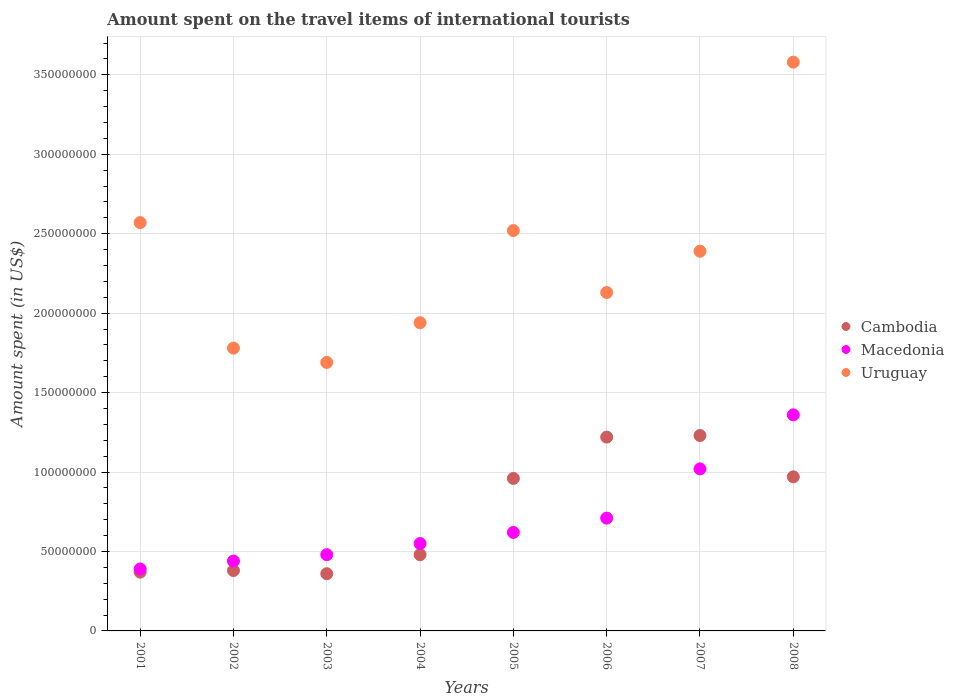How many different coloured dotlines are there?
Ensure brevity in your answer.  3. Is the number of dotlines equal to the number of legend labels?
Keep it short and to the point. Yes. What is the amount spent on the travel items of international tourists in Uruguay in 2007?
Offer a very short reply. 2.39e+08. Across all years, what is the maximum amount spent on the travel items of international tourists in Cambodia?
Ensure brevity in your answer.  1.23e+08. Across all years, what is the minimum amount spent on the travel items of international tourists in Uruguay?
Your answer should be very brief. 1.69e+08. In which year was the amount spent on the travel items of international tourists in Uruguay maximum?
Provide a succinct answer. 2008. What is the total amount spent on the travel items of international tourists in Macedonia in the graph?
Provide a succinct answer. 5.57e+08. What is the difference between the amount spent on the travel items of international tourists in Macedonia in 2001 and that in 2008?
Your answer should be compact. -9.70e+07. What is the difference between the amount spent on the travel items of international tourists in Cambodia in 2005 and the amount spent on the travel items of international tourists in Macedonia in 2008?
Your answer should be compact. -4.00e+07. What is the average amount spent on the travel items of international tourists in Cambodia per year?
Your response must be concise. 7.46e+07. In the year 2005, what is the difference between the amount spent on the travel items of international tourists in Cambodia and amount spent on the travel items of international tourists in Uruguay?
Provide a succinct answer. -1.56e+08. What is the ratio of the amount spent on the travel items of international tourists in Cambodia in 2001 to that in 2002?
Provide a succinct answer. 0.97. What is the difference between the highest and the second highest amount spent on the travel items of international tourists in Macedonia?
Your answer should be very brief. 3.40e+07. What is the difference between the highest and the lowest amount spent on the travel items of international tourists in Macedonia?
Your response must be concise. 9.70e+07. Is the amount spent on the travel items of international tourists in Cambodia strictly greater than the amount spent on the travel items of international tourists in Uruguay over the years?
Make the answer very short. No. Is the amount spent on the travel items of international tourists in Cambodia strictly less than the amount spent on the travel items of international tourists in Uruguay over the years?
Make the answer very short. Yes. How many dotlines are there?
Make the answer very short. 3. Does the graph contain grids?
Your answer should be very brief. Yes. Where does the legend appear in the graph?
Ensure brevity in your answer.  Center right. What is the title of the graph?
Provide a short and direct response. Amount spent on the travel items of international tourists. Does "Guatemala" appear as one of the legend labels in the graph?
Make the answer very short. No. What is the label or title of the Y-axis?
Give a very brief answer. Amount spent (in US$). What is the Amount spent (in US$) of Cambodia in 2001?
Ensure brevity in your answer.  3.70e+07. What is the Amount spent (in US$) in Macedonia in 2001?
Your response must be concise. 3.90e+07. What is the Amount spent (in US$) in Uruguay in 2001?
Provide a short and direct response. 2.57e+08. What is the Amount spent (in US$) in Cambodia in 2002?
Give a very brief answer. 3.80e+07. What is the Amount spent (in US$) in Macedonia in 2002?
Provide a succinct answer. 4.40e+07. What is the Amount spent (in US$) in Uruguay in 2002?
Offer a terse response. 1.78e+08. What is the Amount spent (in US$) of Cambodia in 2003?
Your answer should be compact. 3.60e+07. What is the Amount spent (in US$) in Macedonia in 2003?
Provide a succinct answer. 4.80e+07. What is the Amount spent (in US$) in Uruguay in 2003?
Offer a very short reply. 1.69e+08. What is the Amount spent (in US$) in Cambodia in 2004?
Your answer should be compact. 4.80e+07. What is the Amount spent (in US$) in Macedonia in 2004?
Keep it short and to the point. 5.50e+07. What is the Amount spent (in US$) of Uruguay in 2004?
Your answer should be very brief. 1.94e+08. What is the Amount spent (in US$) in Cambodia in 2005?
Your answer should be compact. 9.60e+07. What is the Amount spent (in US$) of Macedonia in 2005?
Offer a very short reply. 6.20e+07. What is the Amount spent (in US$) in Uruguay in 2005?
Keep it short and to the point. 2.52e+08. What is the Amount spent (in US$) in Cambodia in 2006?
Your response must be concise. 1.22e+08. What is the Amount spent (in US$) in Macedonia in 2006?
Provide a succinct answer. 7.10e+07. What is the Amount spent (in US$) of Uruguay in 2006?
Make the answer very short. 2.13e+08. What is the Amount spent (in US$) in Cambodia in 2007?
Your response must be concise. 1.23e+08. What is the Amount spent (in US$) in Macedonia in 2007?
Give a very brief answer. 1.02e+08. What is the Amount spent (in US$) in Uruguay in 2007?
Ensure brevity in your answer.  2.39e+08. What is the Amount spent (in US$) of Cambodia in 2008?
Ensure brevity in your answer.  9.70e+07. What is the Amount spent (in US$) of Macedonia in 2008?
Offer a terse response. 1.36e+08. What is the Amount spent (in US$) of Uruguay in 2008?
Your answer should be compact. 3.58e+08. Across all years, what is the maximum Amount spent (in US$) in Cambodia?
Provide a short and direct response. 1.23e+08. Across all years, what is the maximum Amount spent (in US$) of Macedonia?
Ensure brevity in your answer.  1.36e+08. Across all years, what is the maximum Amount spent (in US$) in Uruguay?
Your answer should be compact. 3.58e+08. Across all years, what is the minimum Amount spent (in US$) in Cambodia?
Give a very brief answer. 3.60e+07. Across all years, what is the minimum Amount spent (in US$) of Macedonia?
Offer a very short reply. 3.90e+07. Across all years, what is the minimum Amount spent (in US$) of Uruguay?
Your response must be concise. 1.69e+08. What is the total Amount spent (in US$) of Cambodia in the graph?
Ensure brevity in your answer.  5.97e+08. What is the total Amount spent (in US$) in Macedonia in the graph?
Offer a terse response. 5.57e+08. What is the total Amount spent (in US$) in Uruguay in the graph?
Make the answer very short. 1.86e+09. What is the difference between the Amount spent (in US$) of Macedonia in 2001 and that in 2002?
Ensure brevity in your answer.  -5.00e+06. What is the difference between the Amount spent (in US$) of Uruguay in 2001 and that in 2002?
Offer a very short reply. 7.90e+07. What is the difference between the Amount spent (in US$) of Macedonia in 2001 and that in 2003?
Provide a short and direct response. -9.00e+06. What is the difference between the Amount spent (in US$) in Uruguay in 2001 and that in 2003?
Offer a terse response. 8.80e+07. What is the difference between the Amount spent (in US$) in Cambodia in 2001 and that in 2004?
Offer a very short reply. -1.10e+07. What is the difference between the Amount spent (in US$) of Macedonia in 2001 and that in 2004?
Your answer should be compact. -1.60e+07. What is the difference between the Amount spent (in US$) in Uruguay in 2001 and that in 2004?
Offer a terse response. 6.30e+07. What is the difference between the Amount spent (in US$) in Cambodia in 2001 and that in 2005?
Your response must be concise. -5.90e+07. What is the difference between the Amount spent (in US$) in Macedonia in 2001 and that in 2005?
Provide a short and direct response. -2.30e+07. What is the difference between the Amount spent (in US$) in Uruguay in 2001 and that in 2005?
Offer a terse response. 5.00e+06. What is the difference between the Amount spent (in US$) in Cambodia in 2001 and that in 2006?
Provide a short and direct response. -8.50e+07. What is the difference between the Amount spent (in US$) of Macedonia in 2001 and that in 2006?
Give a very brief answer. -3.20e+07. What is the difference between the Amount spent (in US$) of Uruguay in 2001 and that in 2006?
Keep it short and to the point. 4.40e+07. What is the difference between the Amount spent (in US$) in Cambodia in 2001 and that in 2007?
Your answer should be very brief. -8.60e+07. What is the difference between the Amount spent (in US$) in Macedonia in 2001 and that in 2007?
Ensure brevity in your answer.  -6.30e+07. What is the difference between the Amount spent (in US$) of Uruguay in 2001 and that in 2007?
Offer a terse response. 1.80e+07. What is the difference between the Amount spent (in US$) of Cambodia in 2001 and that in 2008?
Your answer should be very brief. -6.00e+07. What is the difference between the Amount spent (in US$) in Macedonia in 2001 and that in 2008?
Make the answer very short. -9.70e+07. What is the difference between the Amount spent (in US$) in Uruguay in 2001 and that in 2008?
Keep it short and to the point. -1.01e+08. What is the difference between the Amount spent (in US$) in Uruguay in 2002 and that in 2003?
Provide a short and direct response. 9.00e+06. What is the difference between the Amount spent (in US$) of Cambodia in 2002 and that in 2004?
Give a very brief answer. -1.00e+07. What is the difference between the Amount spent (in US$) of Macedonia in 2002 and that in 2004?
Offer a very short reply. -1.10e+07. What is the difference between the Amount spent (in US$) of Uruguay in 2002 and that in 2004?
Give a very brief answer. -1.60e+07. What is the difference between the Amount spent (in US$) of Cambodia in 2002 and that in 2005?
Provide a short and direct response. -5.80e+07. What is the difference between the Amount spent (in US$) in Macedonia in 2002 and that in 2005?
Offer a terse response. -1.80e+07. What is the difference between the Amount spent (in US$) in Uruguay in 2002 and that in 2005?
Your answer should be compact. -7.40e+07. What is the difference between the Amount spent (in US$) in Cambodia in 2002 and that in 2006?
Offer a terse response. -8.40e+07. What is the difference between the Amount spent (in US$) in Macedonia in 2002 and that in 2006?
Provide a succinct answer. -2.70e+07. What is the difference between the Amount spent (in US$) of Uruguay in 2002 and that in 2006?
Give a very brief answer. -3.50e+07. What is the difference between the Amount spent (in US$) in Cambodia in 2002 and that in 2007?
Offer a very short reply. -8.50e+07. What is the difference between the Amount spent (in US$) in Macedonia in 2002 and that in 2007?
Give a very brief answer. -5.80e+07. What is the difference between the Amount spent (in US$) of Uruguay in 2002 and that in 2007?
Provide a succinct answer. -6.10e+07. What is the difference between the Amount spent (in US$) of Cambodia in 2002 and that in 2008?
Offer a terse response. -5.90e+07. What is the difference between the Amount spent (in US$) of Macedonia in 2002 and that in 2008?
Give a very brief answer. -9.20e+07. What is the difference between the Amount spent (in US$) in Uruguay in 2002 and that in 2008?
Ensure brevity in your answer.  -1.80e+08. What is the difference between the Amount spent (in US$) in Cambodia in 2003 and that in 2004?
Ensure brevity in your answer.  -1.20e+07. What is the difference between the Amount spent (in US$) in Macedonia in 2003 and that in 2004?
Provide a short and direct response. -7.00e+06. What is the difference between the Amount spent (in US$) of Uruguay in 2003 and that in 2004?
Your answer should be very brief. -2.50e+07. What is the difference between the Amount spent (in US$) in Cambodia in 2003 and that in 2005?
Make the answer very short. -6.00e+07. What is the difference between the Amount spent (in US$) in Macedonia in 2003 and that in 2005?
Your response must be concise. -1.40e+07. What is the difference between the Amount spent (in US$) of Uruguay in 2003 and that in 2005?
Your response must be concise. -8.30e+07. What is the difference between the Amount spent (in US$) in Cambodia in 2003 and that in 2006?
Ensure brevity in your answer.  -8.60e+07. What is the difference between the Amount spent (in US$) in Macedonia in 2003 and that in 2006?
Make the answer very short. -2.30e+07. What is the difference between the Amount spent (in US$) of Uruguay in 2003 and that in 2006?
Your response must be concise. -4.40e+07. What is the difference between the Amount spent (in US$) in Cambodia in 2003 and that in 2007?
Your response must be concise. -8.70e+07. What is the difference between the Amount spent (in US$) of Macedonia in 2003 and that in 2007?
Make the answer very short. -5.40e+07. What is the difference between the Amount spent (in US$) in Uruguay in 2003 and that in 2007?
Give a very brief answer. -7.00e+07. What is the difference between the Amount spent (in US$) in Cambodia in 2003 and that in 2008?
Offer a very short reply. -6.10e+07. What is the difference between the Amount spent (in US$) of Macedonia in 2003 and that in 2008?
Offer a very short reply. -8.80e+07. What is the difference between the Amount spent (in US$) of Uruguay in 2003 and that in 2008?
Your answer should be compact. -1.89e+08. What is the difference between the Amount spent (in US$) in Cambodia in 2004 and that in 2005?
Provide a succinct answer. -4.80e+07. What is the difference between the Amount spent (in US$) in Macedonia in 2004 and that in 2005?
Your answer should be compact. -7.00e+06. What is the difference between the Amount spent (in US$) of Uruguay in 2004 and that in 2005?
Keep it short and to the point. -5.80e+07. What is the difference between the Amount spent (in US$) of Cambodia in 2004 and that in 2006?
Keep it short and to the point. -7.40e+07. What is the difference between the Amount spent (in US$) in Macedonia in 2004 and that in 2006?
Offer a terse response. -1.60e+07. What is the difference between the Amount spent (in US$) of Uruguay in 2004 and that in 2006?
Your answer should be very brief. -1.90e+07. What is the difference between the Amount spent (in US$) of Cambodia in 2004 and that in 2007?
Keep it short and to the point. -7.50e+07. What is the difference between the Amount spent (in US$) in Macedonia in 2004 and that in 2007?
Provide a short and direct response. -4.70e+07. What is the difference between the Amount spent (in US$) of Uruguay in 2004 and that in 2007?
Offer a terse response. -4.50e+07. What is the difference between the Amount spent (in US$) of Cambodia in 2004 and that in 2008?
Provide a succinct answer. -4.90e+07. What is the difference between the Amount spent (in US$) in Macedonia in 2004 and that in 2008?
Offer a very short reply. -8.10e+07. What is the difference between the Amount spent (in US$) in Uruguay in 2004 and that in 2008?
Your answer should be very brief. -1.64e+08. What is the difference between the Amount spent (in US$) in Cambodia in 2005 and that in 2006?
Provide a succinct answer. -2.60e+07. What is the difference between the Amount spent (in US$) of Macedonia in 2005 and that in 2006?
Keep it short and to the point. -9.00e+06. What is the difference between the Amount spent (in US$) in Uruguay in 2005 and that in 2006?
Your answer should be very brief. 3.90e+07. What is the difference between the Amount spent (in US$) of Cambodia in 2005 and that in 2007?
Your answer should be very brief. -2.70e+07. What is the difference between the Amount spent (in US$) in Macedonia in 2005 and that in 2007?
Provide a short and direct response. -4.00e+07. What is the difference between the Amount spent (in US$) in Uruguay in 2005 and that in 2007?
Offer a very short reply. 1.30e+07. What is the difference between the Amount spent (in US$) of Macedonia in 2005 and that in 2008?
Provide a succinct answer. -7.40e+07. What is the difference between the Amount spent (in US$) in Uruguay in 2005 and that in 2008?
Ensure brevity in your answer.  -1.06e+08. What is the difference between the Amount spent (in US$) in Macedonia in 2006 and that in 2007?
Make the answer very short. -3.10e+07. What is the difference between the Amount spent (in US$) of Uruguay in 2006 and that in 2007?
Your response must be concise. -2.60e+07. What is the difference between the Amount spent (in US$) in Cambodia in 2006 and that in 2008?
Give a very brief answer. 2.50e+07. What is the difference between the Amount spent (in US$) in Macedonia in 2006 and that in 2008?
Your answer should be very brief. -6.50e+07. What is the difference between the Amount spent (in US$) in Uruguay in 2006 and that in 2008?
Ensure brevity in your answer.  -1.45e+08. What is the difference between the Amount spent (in US$) of Cambodia in 2007 and that in 2008?
Provide a succinct answer. 2.60e+07. What is the difference between the Amount spent (in US$) in Macedonia in 2007 and that in 2008?
Keep it short and to the point. -3.40e+07. What is the difference between the Amount spent (in US$) in Uruguay in 2007 and that in 2008?
Offer a very short reply. -1.19e+08. What is the difference between the Amount spent (in US$) of Cambodia in 2001 and the Amount spent (in US$) of Macedonia in 2002?
Offer a terse response. -7.00e+06. What is the difference between the Amount spent (in US$) in Cambodia in 2001 and the Amount spent (in US$) in Uruguay in 2002?
Ensure brevity in your answer.  -1.41e+08. What is the difference between the Amount spent (in US$) of Macedonia in 2001 and the Amount spent (in US$) of Uruguay in 2002?
Ensure brevity in your answer.  -1.39e+08. What is the difference between the Amount spent (in US$) of Cambodia in 2001 and the Amount spent (in US$) of Macedonia in 2003?
Keep it short and to the point. -1.10e+07. What is the difference between the Amount spent (in US$) in Cambodia in 2001 and the Amount spent (in US$) in Uruguay in 2003?
Your answer should be compact. -1.32e+08. What is the difference between the Amount spent (in US$) in Macedonia in 2001 and the Amount spent (in US$) in Uruguay in 2003?
Your answer should be compact. -1.30e+08. What is the difference between the Amount spent (in US$) of Cambodia in 2001 and the Amount spent (in US$) of Macedonia in 2004?
Your answer should be very brief. -1.80e+07. What is the difference between the Amount spent (in US$) in Cambodia in 2001 and the Amount spent (in US$) in Uruguay in 2004?
Offer a terse response. -1.57e+08. What is the difference between the Amount spent (in US$) in Macedonia in 2001 and the Amount spent (in US$) in Uruguay in 2004?
Your response must be concise. -1.55e+08. What is the difference between the Amount spent (in US$) of Cambodia in 2001 and the Amount spent (in US$) of Macedonia in 2005?
Your response must be concise. -2.50e+07. What is the difference between the Amount spent (in US$) of Cambodia in 2001 and the Amount spent (in US$) of Uruguay in 2005?
Your answer should be very brief. -2.15e+08. What is the difference between the Amount spent (in US$) of Macedonia in 2001 and the Amount spent (in US$) of Uruguay in 2005?
Ensure brevity in your answer.  -2.13e+08. What is the difference between the Amount spent (in US$) of Cambodia in 2001 and the Amount spent (in US$) of Macedonia in 2006?
Your answer should be compact. -3.40e+07. What is the difference between the Amount spent (in US$) in Cambodia in 2001 and the Amount spent (in US$) in Uruguay in 2006?
Give a very brief answer. -1.76e+08. What is the difference between the Amount spent (in US$) in Macedonia in 2001 and the Amount spent (in US$) in Uruguay in 2006?
Your answer should be very brief. -1.74e+08. What is the difference between the Amount spent (in US$) in Cambodia in 2001 and the Amount spent (in US$) in Macedonia in 2007?
Offer a terse response. -6.50e+07. What is the difference between the Amount spent (in US$) in Cambodia in 2001 and the Amount spent (in US$) in Uruguay in 2007?
Your response must be concise. -2.02e+08. What is the difference between the Amount spent (in US$) in Macedonia in 2001 and the Amount spent (in US$) in Uruguay in 2007?
Keep it short and to the point. -2.00e+08. What is the difference between the Amount spent (in US$) of Cambodia in 2001 and the Amount spent (in US$) of Macedonia in 2008?
Keep it short and to the point. -9.90e+07. What is the difference between the Amount spent (in US$) of Cambodia in 2001 and the Amount spent (in US$) of Uruguay in 2008?
Ensure brevity in your answer.  -3.21e+08. What is the difference between the Amount spent (in US$) of Macedonia in 2001 and the Amount spent (in US$) of Uruguay in 2008?
Your answer should be compact. -3.19e+08. What is the difference between the Amount spent (in US$) in Cambodia in 2002 and the Amount spent (in US$) in Macedonia in 2003?
Your answer should be very brief. -1.00e+07. What is the difference between the Amount spent (in US$) of Cambodia in 2002 and the Amount spent (in US$) of Uruguay in 2003?
Provide a short and direct response. -1.31e+08. What is the difference between the Amount spent (in US$) in Macedonia in 2002 and the Amount spent (in US$) in Uruguay in 2003?
Keep it short and to the point. -1.25e+08. What is the difference between the Amount spent (in US$) in Cambodia in 2002 and the Amount spent (in US$) in Macedonia in 2004?
Your response must be concise. -1.70e+07. What is the difference between the Amount spent (in US$) in Cambodia in 2002 and the Amount spent (in US$) in Uruguay in 2004?
Provide a succinct answer. -1.56e+08. What is the difference between the Amount spent (in US$) in Macedonia in 2002 and the Amount spent (in US$) in Uruguay in 2004?
Make the answer very short. -1.50e+08. What is the difference between the Amount spent (in US$) of Cambodia in 2002 and the Amount spent (in US$) of Macedonia in 2005?
Your answer should be very brief. -2.40e+07. What is the difference between the Amount spent (in US$) of Cambodia in 2002 and the Amount spent (in US$) of Uruguay in 2005?
Offer a terse response. -2.14e+08. What is the difference between the Amount spent (in US$) of Macedonia in 2002 and the Amount spent (in US$) of Uruguay in 2005?
Make the answer very short. -2.08e+08. What is the difference between the Amount spent (in US$) of Cambodia in 2002 and the Amount spent (in US$) of Macedonia in 2006?
Your answer should be very brief. -3.30e+07. What is the difference between the Amount spent (in US$) of Cambodia in 2002 and the Amount spent (in US$) of Uruguay in 2006?
Offer a very short reply. -1.75e+08. What is the difference between the Amount spent (in US$) of Macedonia in 2002 and the Amount spent (in US$) of Uruguay in 2006?
Keep it short and to the point. -1.69e+08. What is the difference between the Amount spent (in US$) in Cambodia in 2002 and the Amount spent (in US$) in Macedonia in 2007?
Provide a succinct answer. -6.40e+07. What is the difference between the Amount spent (in US$) in Cambodia in 2002 and the Amount spent (in US$) in Uruguay in 2007?
Provide a succinct answer. -2.01e+08. What is the difference between the Amount spent (in US$) in Macedonia in 2002 and the Amount spent (in US$) in Uruguay in 2007?
Ensure brevity in your answer.  -1.95e+08. What is the difference between the Amount spent (in US$) in Cambodia in 2002 and the Amount spent (in US$) in Macedonia in 2008?
Provide a short and direct response. -9.80e+07. What is the difference between the Amount spent (in US$) of Cambodia in 2002 and the Amount spent (in US$) of Uruguay in 2008?
Provide a short and direct response. -3.20e+08. What is the difference between the Amount spent (in US$) of Macedonia in 2002 and the Amount spent (in US$) of Uruguay in 2008?
Offer a terse response. -3.14e+08. What is the difference between the Amount spent (in US$) of Cambodia in 2003 and the Amount spent (in US$) of Macedonia in 2004?
Your answer should be compact. -1.90e+07. What is the difference between the Amount spent (in US$) in Cambodia in 2003 and the Amount spent (in US$) in Uruguay in 2004?
Offer a very short reply. -1.58e+08. What is the difference between the Amount spent (in US$) of Macedonia in 2003 and the Amount spent (in US$) of Uruguay in 2004?
Give a very brief answer. -1.46e+08. What is the difference between the Amount spent (in US$) of Cambodia in 2003 and the Amount spent (in US$) of Macedonia in 2005?
Provide a succinct answer. -2.60e+07. What is the difference between the Amount spent (in US$) in Cambodia in 2003 and the Amount spent (in US$) in Uruguay in 2005?
Keep it short and to the point. -2.16e+08. What is the difference between the Amount spent (in US$) of Macedonia in 2003 and the Amount spent (in US$) of Uruguay in 2005?
Your response must be concise. -2.04e+08. What is the difference between the Amount spent (in US$) of Cambodia in 2003 and the Amount spent (in US$) of Macedonia in 2006?
Provide a short and direct response. -3.50e+07. What is the difference between the Amount spent (in US$) of Cambodia in 2003 and the Amount spent (in US$) of Uruguay in 2006?
Make the answer very short. -1.77e+08. What is the difference between the Amount spent (in US$) of Macedonia in 2003 and the Amount spent (in US$) of Uruguay in 2006?
Offer a terse response. -1.65e+08. What is the difference between the Amount spent (in US$) of Cambodia in 2003 and the Amount spent (in US$) of Macedonia in 2007?
Offer a terse response. -6.60e+07. What is the difference between the Amount spent (in US$) in Cambodia in 2003 and the Amount spent (in US$) in Uruguay in 2007?
Your answer should be very brief. -2.03e+08. What is the difference between the Amount spent (in US$) in Macedonia in 2003 and the Amount spent (in US$) in Uruguay in 2007?
Offer a terse response. -1.91e+08. What is the difference between the Amount spent (in US$) in Cambodia in 2003 and the Amount spent (in US$) in Macedonia in 2008?
Provide a succinct answer. -1.00e+08. What is the difference between the Amount spent (in US$) in Cambodia in 2003 and the Amount spent (in US$) in Uruguay in 2008?
Your answer should be compact. -3.22e+08. What is the difference between the Amount spent (in US$) in Macedonia in 2003 and the Amount spent (in US$) in Uruguay in 2008?
Provide a short and direct response. -3.10e+08. What is the difference between the Amount spent (in US$) of Cambodia in 2004 and the Amount spent (in US$) of Macedonia in 2005?
Keep it short and to the point. -1.40e+07. What is the difference between the Amount spent (in US$) in Cambodia in 2004 and the Amount spent (in US$) in Uruguay in 2005?
Make the answer very short. -2.04e+08. What is the difference between the Amount spent (in US$) in Macedonia in 2004 and the Amount spent (in US$) in Uruguay in 2005?
Offer a very short reply. -1.97e+08. What is the difference between the Amount spent (in US$) of Cambodia in 2004 and the Amount spent (in US$) of Macedonia in 2006?
Your answer should be very brief. -2.30e+07. What is the difference between the Amount spent (in US$) in Cambodia in 2004 and the Amount spent (in US$) in Uruguay in 2006?
Provide a succinct answer. -1.65e+08. What is the difference between the Amount spent (in US$) in Macedonia in 2004 and the Amount spent (in US$) in Uruguay in 2006?
Ensure brevity in your answer.  -1.58e+08. What is the difference between the Amount spent (in US$) of Cambodia in 2004 and the Amount spent (in US$) of Macedonia in 2007?
Give a very brief answer. -5.40e+07. What is the difference between the Amount spent (in US$) of Cambodia in 2004 and the Amount spent (in US$) of Uruguay in 2007?
Your answer should be very brief. -1.91e+08. What is the difference between the Amount spent (in US$) in Macedonia in 2004 and the Amount spent (in US$) in Uruguay in 2007?
Your response must be concise. -1.84e+08. What is the difference between the Amount spent (in US$) in Cambodia in 2004 and the Amount spent (in US$) in Macedonia in 2008?
Offer a very short reply. -8.80e+07. What is the difference between the Amount spent (in US$) in Cambodia in 2004 and the Amount spent (in US$) in Uruguay in 2008?
Offer a very short reply. -3.10e+08. What is the difference between the Amount spent (in US$) of Macedonia in 2004 and the Amount spent (in US$) of Uruguay in 2008?
Offer a terse response. -3.03e+08. What is the difference between the Amount spent (in US$) in Cambodia in 2005 and the Amount spent (in US$) in Macedonia in 2006?
Your answer should be compact. 2.50e+07. What is the difference between the Amount spent (in US$) in Cambodia in 2005 and the Amount spent (in US$) in Uruguay in 2006?
Ensure brevity in your answer.  -1.17e+08. What is the difference between the Amount spent (in US$) in Macedonia in 2005 and the Amount spent (in US$) in Uruguay in 2006?
Give a very brief answer. -1.51e+08. What is the difference between the Amount spent (in US$) in Cambodia in 2005 and the Amount spent (in US$) in Macedonia in 2007?
Your response must be concise. -6.00e+06. What is the difference between the Amount spent (in US$) of Cambodia in 2005 and the Amount spent (in US$) of Uruguay in 2007?
Provide a short and direct response. -1.43e+08. What is the difference between the Amount spent (in US$) in Macedonia in 2005 and the Amount spent (in US$) in Uruguay in 2007?
Offer a terse response. -1.77e+08. What is the difference between the Amount spent (in US$) of Cambodia in 2005 and the Amount spent (in US$) of Macedonia in 2008?
Provide a short and direct response. -4.00e+07. What is the difference between the Amount spent (in US$) in Cambodia in 2005 and the Amount spent (in US$) in Uruguay in 2008?
Provide a short and direct response. -2.62e+08. What is the difference between the Amount spent (in US$) of Macedonia in 2005 and the Amount spent (in US$) of Uruguay in 2008?
Provide a short and direct response. -2.96e+08. What is the difference between the Amount spent (in US$) in Cambodia in 2006 and the Amount spent (in US$) in Macedonia in 2007?
Your answer should be very brief. 2.00e+07. What is the difference between the Amount spent (in US$) of Cambodia in 2006 and the Amount spent (in US$) of Uruguay in 2007?
Keep it short and to the point. -1.17e+08. What is the difference between the Amount spent (in US$) of Macedonia in 2006 and the Amount spent (in US$) of Uruguay in 2007?
Your answer should be compact. -1.68e+08. What is the difference between the Amount spent (in US$) of Cambodia in 2006 and the Amount spent (in US$) of Macedonia in 2008?
Ensure brevity in your answer.  -1.40e+07. What is the difference between the Amount spent (in US$) of Cambodia in 2006 and the Amount spent (in US$) of Uruguay in 2008?
Provide a short and direct response. -2.36e+08. What is the difference between the Amount spent (in US$) in Macedonia in 2006 and the Amount spent (in US$) in Uruguay in 2008?
Give a very brief answer. -2.87e+08. What is the difference between the Amount spent (in US$) of Cambodia in 2007 and the Amount spent (in US$) of Macedonia in 2008?
Ensure brevity in your answer.  -1.30e+07. What is the difference between the Amount spent (in US$) of Cambodia in 2007 and the Amount spent (in US$) of Uruguay in 2008?
Offer a very short reply. -2.35e+08. What is the difference between the Amount spent (in US$) of Macedonia in 2007 and the Amount spent (in US$) of Uruguay in 2008?
Offer a terse response. -2.56e+08. What is the average Amount spent (in US$) in Cambodia per year?
Give a very brief answer. 7.46e+07. What is the average Amount spent (in US$) of Macedonia per year?
Provide a short and direct response. 6.96e+07. What is the average Amount spent (in US$) in Uruguay per year?
Ensure brevity in your answer.  2.32e+08. In the year 2001, what is the difference between the Amount spent (in US$) in Cambodia and Amount spent (in US$) in Macedonia?
Offer a terse response. -2.00e+06. In the year 2001, what is the difference between the Amount spent (in US$) of Cambodia and Amount spent (in US$) of Uruguay?
Keep it short and to the point. -2.20e+08. In the year 2001, what is the difference between the Amount spent (in US$) of Macedonia and Amount spent (in US$) of Uruguay?
Provide a short and direct response. -2.18e+08. In the year 2002, what is the difference between the Amount spent (in US$) of Cambodia and Amount spent (in US$) of Macedonia?
Make the answer very short. -6.00e+06. In the year 2002, what is the difference between the Amount spent (in US$) in Cambodia and Amount spent (in US$) in Uruguay?
Your answer should be compact. -1.40e+08. In the year 2002, what is the difference between the Amount spent (in US$) in Macedonia and Amount spent (in US$) in Uruguay?
Offer a terse response. -1.34e+08. In the year 2003, what is the difference between the Amount spent (in US$) in Cambodia and Amount spent (in US$) in Macedonia?
Offer a very short reply. -1.20e+07. In the year 2003, what is the difference between the Amount spent (in US$) of Cambodia and Amount spent (in US$) of Uruguay?
Give a very brief answer. -1.33e+08. In the year 2003, what is the difference between the Amount spent (in US$) of Macedonia and Amount spent (in US$) of Uruguay?
Your answer should be very brief. -1.21e+08. In the year 2004, what is the difference between the Amount spent (in US$) of Cambodia and Amount spent (in US$) of Macedonia?
Keep it short and to the point. -7.00e+06. In the year 2004, what is the difference between the Amount spent (in US$) in Cambodia and Amount spent (in US$) in Uruguay?
Your answer should be very brief. -1.46e+08. In the year 2004, what is the difference between the Amount spent (in US$) in Macedonia and Amount spent (in US$) in Uruguay?
Provide a succinct answer. -1.39e+08. In the year 2005, what is the difference between the Amount spent (in US$) in Cambodia and Amount spent (in US$) in Macedonia?
Offer a very short reply. 3.40e+07. In the year 2005, what is the difference between the Amount spent (in US$) of Cambodia and Amount spent (in US$) of Uruguay?
Make the answer very short. -1.56e+08. In the year 2005, what is the difference between the Amount spent (in US$) of Macedonia and Amount spent (in US$) of Uruguay?
Offer a terse response. -1.90e+08. In the year 2006, what is the difference between the Amount spent (in US$) of Cambodia and Amount spent (in US$) of Macedonia?
Offer a very short reply. 5.10e+07. In the year 2006, what is the difference between the Amount spent (in US$) in Cambodia and Amount spent (in US$) in Uruguay?
Your response must be concise. -9.10e+07. In the year 2006, what is the difference between the Amount spent (in US$) in Macedonia and Amount spent (in US$) in Uruguay?
Provide a short and direct response. -1.42e+08. In the year 2007, what is the difference between the Amount spent (in US$) in Cambodia and Amount spent (in US$) in Macedonia?
Offer a terse response. 2.10e+07. In the year 2007, what is the difference between the Amount spent (in US$) in Cambodia and Amount spent (in US$) in Uruguay?
Offer a terse response. -1.16e+08. In the year 2007, what is the difference between the Amount spent (in US$) of Macedonia and Amount spent (in US$) of Uruguay?
Keep it short and to the point. -1.37e+08. In the year 2008, what is the difference between the Amount spent (in US$) of Cambodia and Amount spent (in US$) of Macedonia?
Offer a very short reply. -3.90e+07. In the year 2008, what is the difference between the Amount spent (in US$) of Cambodia and Amount spent (in US$) of Uruguay?
Keep it short and to the point. -2.61e+08. In the year 2008, what is the difference between the Amount spent (in US$) in Macedonia and Amount spent (in US$) in Uruguay?
Your response must be concise. -2.22e+08. What is the ratio of the Amount spent (in US$) of Cambodia in 2001 to that in 2002?
Give a very brief answer. 0.97. What is the ratio of the Amount spent (in US$) of Macedonia in 2001 to that in 2002?
Provide a short and direct response. 0.89. What is the ratio of the Amount spent (in US$) of Uruguay in 2001 to that in 2002?
Keep it short and to the point. 1.44. What is the ratio of the Amount spent (in US$) of Cambodia in 2001 to that in 2003?
Make the answer very short. 1.03. What is the ratio of the Amount spent (in US$) in Macedonia in 2001 to that in 2003?
Your response must be concise. 0.81. What is the ratio of the Amount spent (in US$) of Uruguay in 2001 to that in 2003?
Keep it short and to the point. 1.52. What is the ratio of the Amount spent (in US$) in Cambodia in 2001 to that in 2004?
Provide a short and direct response. 0.77. What is the ratio of the Amount spent (in US$) of Macedonia in 2001 to that in 2004?
Make the answer very short. 0.71. What is the ratio of the Amount spent (in US$) of Uruguay in 2001 to that in 2004?
Offer a very short reply. 1.32. What is the ratio of the Amount spent (in US$) in Cambodia in 2001 to that in 2005?
Keep it short and to the point. 0.39. What is the ratio of the Amount spent (in US$) of Macedonia in 2001 to that in 2005?
Provide a short and direct response. 0.63. What is the ratio of the Amount spent (in US$) in Uruguay in 2001 to that in 2005?
Ensure brevity in your answer.  1.02. What is the ratio of the Amount spent (in US$) in Cambodia in 2001 to that in 2006?
Ensure brevity in your answer.  0.3. What is the ratio of the Amount spent (in US$) of Macedonia in 2001 to that in 2006?
Keep it short and to the point. 0.55. What is the ratio of the Amount spent (in US$) in Uruguay in 2001 to that in 2006?
Your answer should be compact. 1.21. What is the ratio of the Amount spent (in US$) in Cambodia in 2001 to that in 2007?
Your answer should be compact. 0.3. What is the ratio of the Amount spent (in US$) of Macedonia in 2001 to that in 2007?
Make the answer very short. 0.38. What is the ratio of the Amount spent (in US$) of Uruguay in 2001 to that in 2007?
Your answer should be very brief. 1.08. What is the ratio of the Amount spent (in US$) in Cambodia in 2001 to that in 2008?
Make the answer very short. 0.38. What is the ratio of the Amount spent (in US$) in Macedonia in 2001 to that in 2008?
Your answer should be compact. 0.29. What is the ratio of the Amount spent (in US$) of Uruguay in 2001 to that in 2008?
Keep it short and to the point. 0.72. What is the ratio of the Amount spent (in US$) of Cambodia in 2002 to that in 2003?
Your answer should be compact. 1.06. What is the ratio of the Amount spent (in US$) in Uruguay in 2002 to that in 2003?
Your response must be concise. 1.05. What is the ratio of the Amount spent (in US$) in Cambodia in 2002 to that in 2004?
Your answer should be compact. 0.79. What is the ratio of the Amount spent (in US$) of Uruguay in 2002 to that in 2004?
Give a very brief answer. 0.92. What is the ratio of the Amount spent (in US$) of Cambodia in 2002 to that in 2005?
Your answer should be very brief. 0.4. What is the ratio of the Amount spent (in US$) in Macedonia in 2002 to that in 2005?
Your answer should be compact. 0.71. What is the ratio of the Amount spent (in US$) in Uruguay in 2002 to that in 2005?
Your answer should be compact. 0.71. What is the ratio of the Amount spent (in US$) in Cambodia in 2002 to that in 2006?
Your response must be concise. 0.31. What is the ratio of the Amount spent (in US$) in Macedonia in 2002 to that in 2006?
Your answer should be very brief. 0.62. What is the ratio of the Amount spent (in US$) in Uruguay in 2002 to that in 2006?
Your answer should be very brief. 0.84. What is the ratio of the Amount spent (in US$) of Cambodia in 2002 to that in 2007?
Offer a terse response. 0.31. What is the ratio of the Amount spent (in US$) of Macedonia in 2002 to that in 2007?
Keep it short and to the point. 0.43. What is the ratio of the Amount spent (in US$) in Uruguay in 2002 to that in 2007?
Your answer should be compact. 0.74. What is the ratio of the Amount spent (in US$) in Cambodia in 2002 to that in 2008?
Provide a short and direct response. 0.39. What is the ratio of the Amount spent (in US$) in Macedonia in 2002 to that in 2008?
Your answer should be compact. 0.32. What is the ratio of the Amount spent (in US$) in Uruguay in 2002 to that in 2008?
Offer a very short reply. 0.5. What is the ratio of the Amount spent (in US$) of Macedonia in 2003 to that in 2004?
Keep it short and to the point. 0.87. What is the ratio of the Amount spent (in US$) of Uruguay in 2003 to that in 2004?
Provide a succinct answer. 0.87. What is the ratio of the Amount spent (in US$) in Macedonia in 2003 to that in 2005?
Your answer should be very brief. 0.77. What is the ratio of the Amount spent (in US$) in Uruguay in 2003 to that in 2005?
Offer a very short reply. 0.67. What is the ratio of the Amount spent (in US$) of Cambodia in 2003 to that in 2006?
Provide a succinct answer. 0.3. What is the ratio of the Amount spent (in US$) of Macedonia in 2003 to that in 2006?
Give a very brief answer. 0.68. What is the ratio of the Amount spent (in US$) in Uruguay in 2003 to that in 2006?
Ensure brevity in your answer.  0.79. What is the ratio of the Amount spent (in US$) of Cambodia in 2003 to that in 2007?
Keep it short and to the point. 0.29. What is the ratio of the Amount spent (in US$) in Macedonia in 2003 to that in 2007?
Make the answer very short. 0.47. What is the ratio of the Amount spent (in US$) of Uruguay in 2003 to that in 2007?
Keep it short and to the point. 0.71. What is the ratio of the Amount spent (in US$) in Cambodia in 2003 to that in 2008?
Offer a terse response. 0.37. What is the ratio of the Amount spent (in US$) of Macedonia in 2003 to that in 2008?
Provide a short and direct response. 0.35. What is the ratio of the Amount spent (in US$) in Uruguay in 2003 to that in 2008?
Provide a short and direct response. 0.47. What is the ratio of the Amount spent (in US$) in Cambodia in 2004 to that in 2005?
Provide a succinct answer. 0.5. What is the ratio of the Amount spent (in US$) in Macedonia in 2004 to that in 2005?
Your answer should be very brief. 0.89. What is the ratio of the Amount spent (in US$) of Uruguay in 2004 to that in 2005?
Provide a short and direct response. 0.77. What is the ratio of the Amount spent (in US$) in Cambodia in 2004 to that in 2006?
Provide a short and direct response. 0.39. What is the ratio of the Amount spent (in US$) in Macedonia in 2004 to that in 2006?
Keep it short and to the point. 0.77. What is the ratio of the Amount spent (in US$) of Uruguay in 2004 to that in 2006?
Your response must be concise. 0.91. What is the ratio of the Amount spent (in US$) of Cambodia in 2004 to that in 2007?
Ensure brevity in your answer.  0.39. What is the ratio of the Amount spent (in US$) in Macedonia in 2004 to that in 2007?
Your answer should be compact. 0.54. What is the ratio of the Amount spent (in US$) in Uruguay in 2004 to that in 2007?
Your response must be concise. 0.81. What is the ratio of the Amount spent (in US$) of Cambodia in 2004 to that in 2008?
Keep it short and to the point. 0.49. What is the ratio of the Amount spent (in US$) of Macedonia in 2004 to that in 2008?
Keep it short and to the point. 0.4. What is the ratio of the Amount spent (in US$) of Uruguay in 2004 to that in 2008?
Your answer should be compact. 0.54. What is the ratio of the Amount spent (in US$) in Cambodia in 2005 to that in 2006?
Provide a succinct answer. 0.79. What is the ratio of the Amount spent (in US$) in Macedonia in 2005 to that in 2006?
Keep it short and to the point. 0.87. What is the ratio of the Amount spent (in US$) in Uruguay in 2005 to that in 2006?
Provide a succinct answer. 1.18. What is the ratio of the Amount spent (in US$) of Cambodia in 2005 to that in 2007?
Keep it short and to the point. 0.78. What is the ratio of the Amount spent (in US$) of Macedonia in 2005 to that in 2007?
Offer a terse response. 0.61. What is the ratio of the Amount spent (in US$) in Uruguay in 2005 to that in 2007?
Your answer should be very brief. 1.05. What is the ratio of the Amount spent (in US$) in Macedonia in 2005 to that in 2008?
Keep it short and to the point. 0.46. What is the ratio of the Amount spent (in US$) of Uruguay in 2005 to that in 2008?
Your answer should be very brief. 0.7. What is the ratio of the Amount spent (in US$) of Macedonia in 2006 to that in 2007?
Ensure brevity in your answer.  0.7. What is the ratio of the Amount spent (in US$) in Uruguay in 2006 to that in 2007?
Make the answer very short. 0.89. What is the ratio of the Amount spent (in US$) in Cambodia in 2006 to that in 2008?
Your response must be concise. 1.26. What is the ratio of the Amount spent (in US$) of Macedonia in 2006 to that in 2008?
Provide a short and direct response. 0.52. What is the ratio of the Amount spent (in US$) in Uruguay in 2006 to that in 2008?
Give a very brief answer. 0.59. What is the ratio of the Amount spent (in US$) in Cambodia in 2007 to that in 2008?
Your answer should be very brief. 1.27. What is the ratio of the Amount spent (in US$) in Uruguay in 2007 to that in 2008?
Make the answer very short. 0.67. What is the difference between the highest and the second highest Amount spent (in US$) of Macedonia?
Your response must be concise. 3.40e+07. What is the difference between the highest and the second highest Amount spent (in US$) in Uruguay?
Ensure brevity in your answer.  1.01e+08. What is the difference between the highest and the lowest Amount spent (in US$) in Cambodia?
Make the answer very short. 8.70e+07. What is the difference between the highest and the lowest Amount spent (in US$) of Macedonia?
Your answer should be very brief. 9.70e+07. What is the difference between the highest and the lowest Amount spent (in US$) of Uruguay?
Offer a terse response. 1.89e+08. 